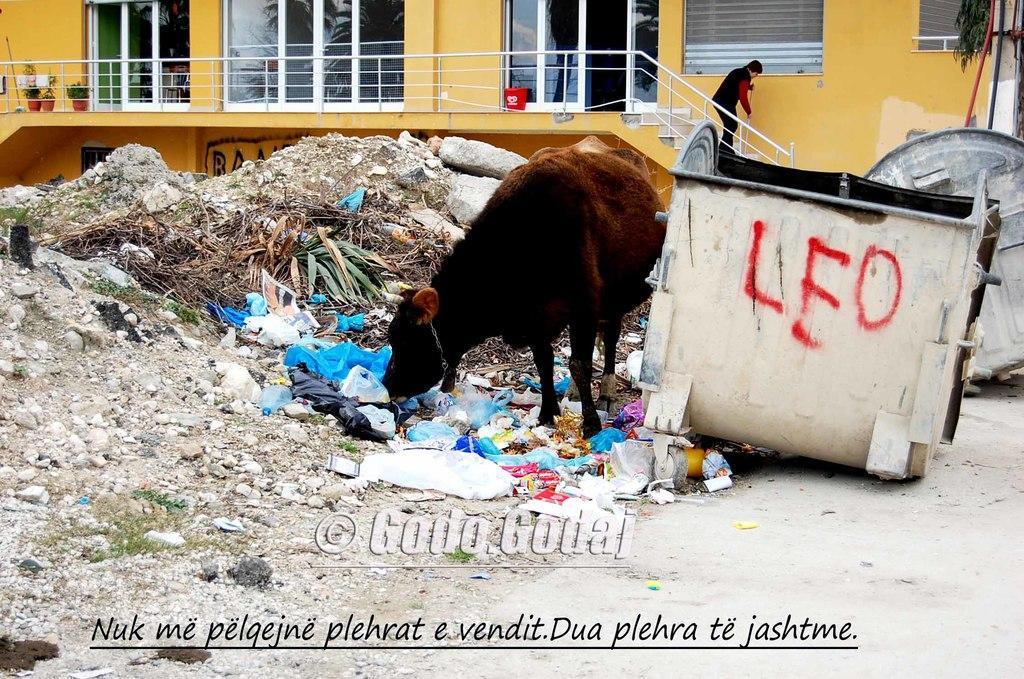Describe this image in one or two sentences. In this image in the center there is an animal standing and there are stones on the ground and there are objects which seems to be plastic. In the background there is a building, there are plants, there are windows and there is a door and the person standing on the stairs and there is an object which is white in colour with some text written on it which is in the center. 